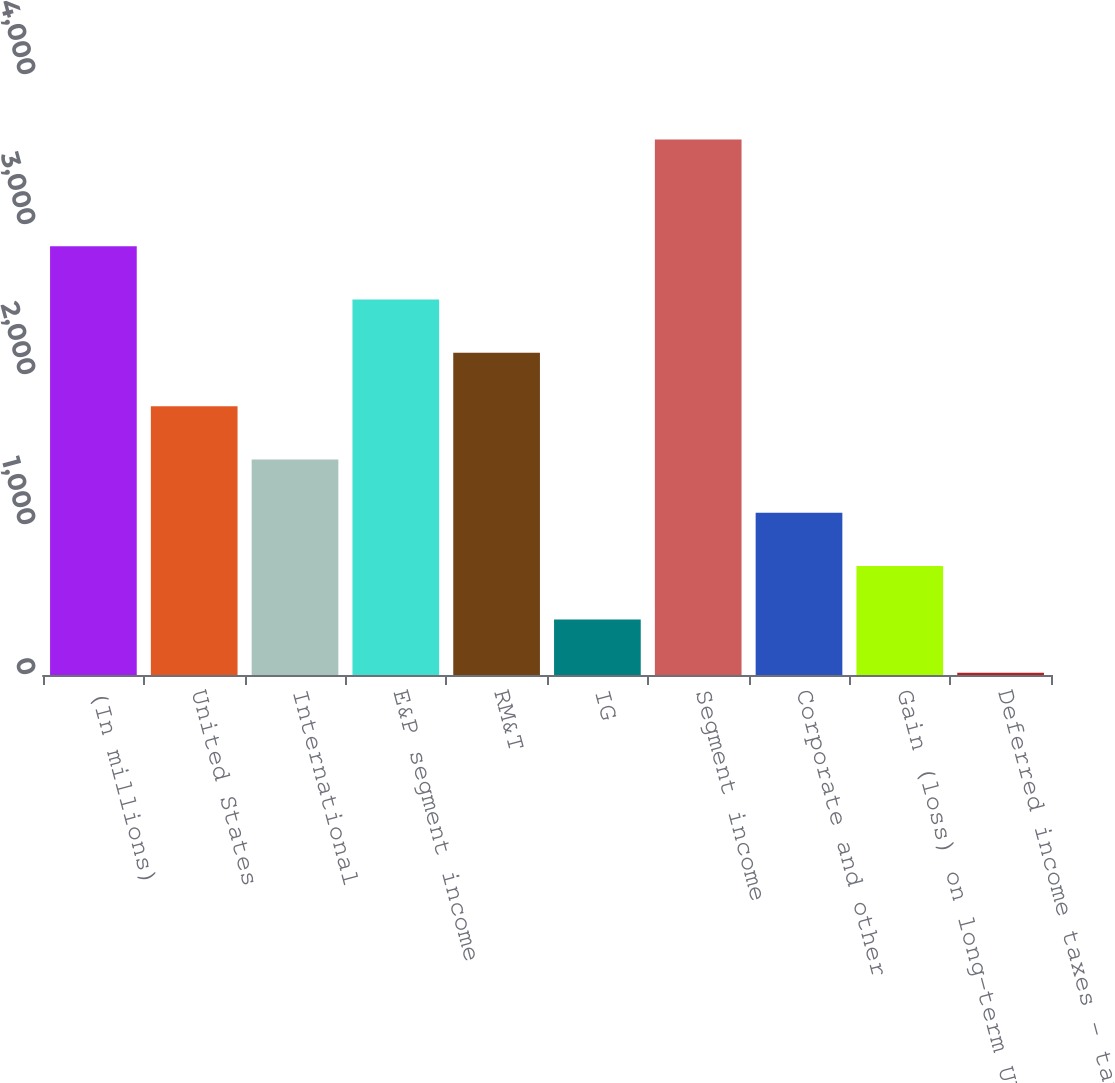Convert chart to OTSL. <chart><loc_0><loc_0><loc_500><loc_500><bar_chart><fcel>(In millions)<fcel>United States<fcel>International<fcel>E&P segment income<fcel>RM&T<fcel>IG<fcel>Segment income<fcel>Corporate and other<fcel>Gain (loss) on long-term UK<fcel>Deferred income taxes - tax<nl><fcel>2859<fcel>1792.5<fcel>1437<fcel>2503.5<fcel>2148<fcel>370.5<fcel>3570<fcel>1081.5<fcel>726<fcel>15<nl></chart> 